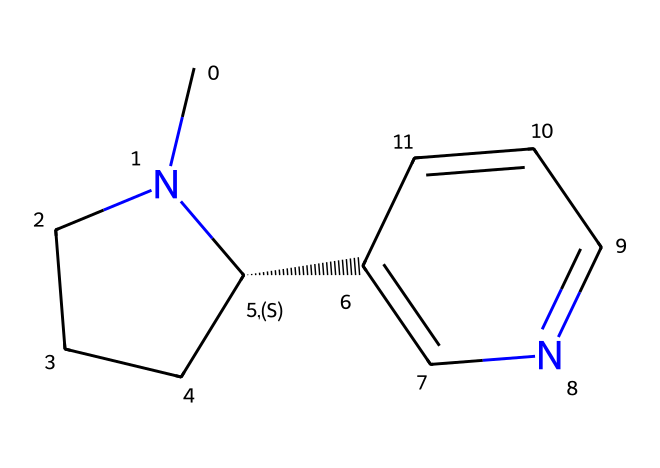What is the name of this chemical? The SMILES representation corresponds to nicotine, which is a well-known alkaloid found in tobacco.
Answer: nicotine How many nitrogen atoms are in this compound? By analyzing the structure represented in the SMILES, we can see that there are two nitrogen atoms present in the rings.
Answer: 2 What type of compound is nicotine? Nicotine is classified as an alkaloid, which is a class of naturally occurring organic compounds containing basic nitrogen atoms.
Answer: alkaloid How many aromatic rings does the nicotine structure contain? The structure contains one aromatic ring indicated by the alternating double bonds within one of the cyclic portions of the molecule.
Answer: 1 What is the hybridization state of the nitrogen atoms in nicotine? The nitrogen atoms in the structure exhibit sp2 hybridization, which is common in aromatic compounds due to their participation in resonance.
Answer: sp2 How does the structure of nicotine enable it to act as a neurotransmitter? The presence of nitrogen atoms allows nicotine to interact with acetylcholine receptors due to its basic nature, enabling neurotransmission.
Answer: acetylcholine What physical state is nicotine at room temperature? Given its molecular structure and low molecular weight, nicotine is a liquid at room temperature.
Answer: liquid 